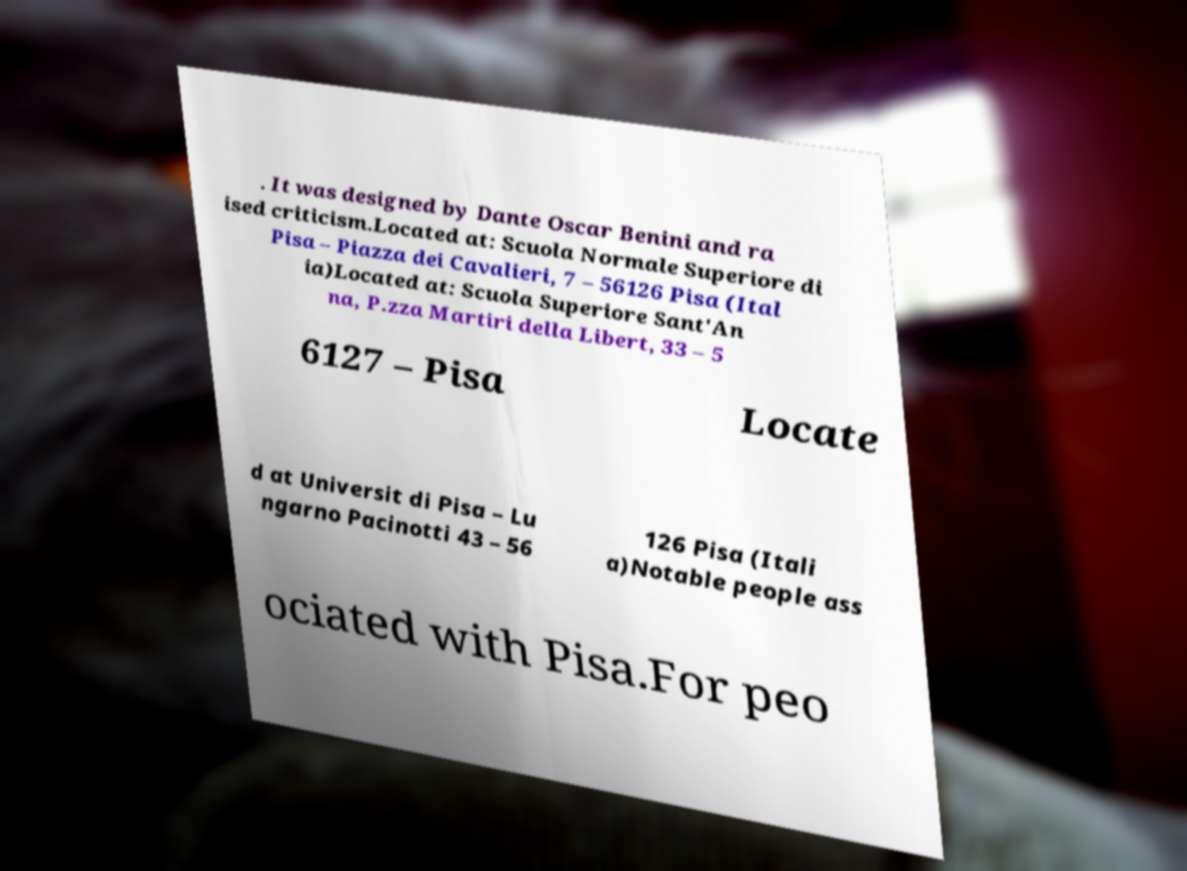Can you read and provide the text displayed in the image?This photo seems to have some interesting text. Can you extract and type it out for me? . It was designed by Dante Oscar Benini and ra ised criticism.Located at: Scuola Normale Superiore di Pisa – Piazza dei Cavalieri, 7 – 56126 Pisa (Ital ia)Located at: Scuola Superiore Sant'An na, P.zza Martiri della Libert, 33 – 5 6127 – Pisa Locate d at Universit di Pisa – Lu ngarno Pacinotti 43 – 56 126 Pisa (Itali a)Notable people ass ociated with Pisa.For peo 